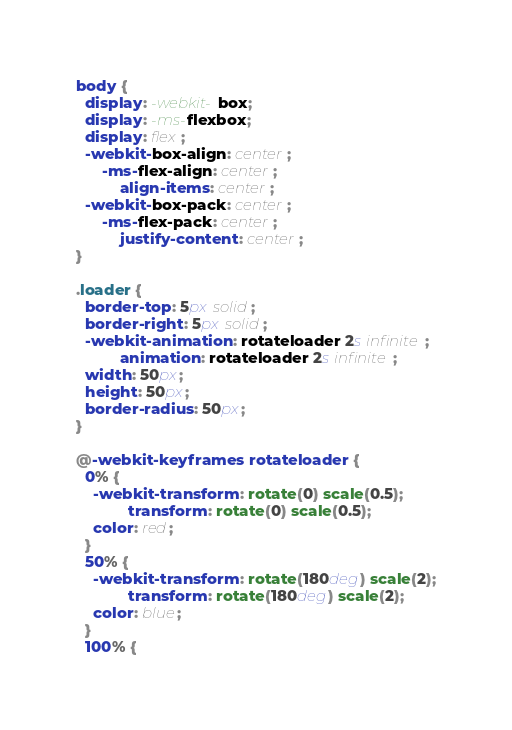<code> <loc_0><loc_0><loc_500><loc_500><_CSS_>body {
  display: -webkit-box;
  display: -ms-flexbox;
  display: flex;
  -webkit-box-align: center;
      -ms-flex-align: center;
          align-items: center;
  -webkit-box-pack: center;
      -ms-flex-pack: center;
          justify-content: center;
}

.loader {
  border-top: 5px solid;
  border-right: 5px solid;
  -webkit-animation: rotateloader 2s infinite;
          animation: rotateloader 2s infinite;
  width: 50px;
  height: 50px;
  border-radius: 50px;
}

@-webkit-keyframes rotateloader {
  0% {
    -webkit-transform: rotate(0) scale(0.5);
            transform: rotate(0) scale(0.5);
    color: red;
  }
  50% {
    -webkit-transform: rotate(180deg) scale(2);
            transform: rotate(180deg) scale(2);
    color: blue;
  }
  100% {</code> 